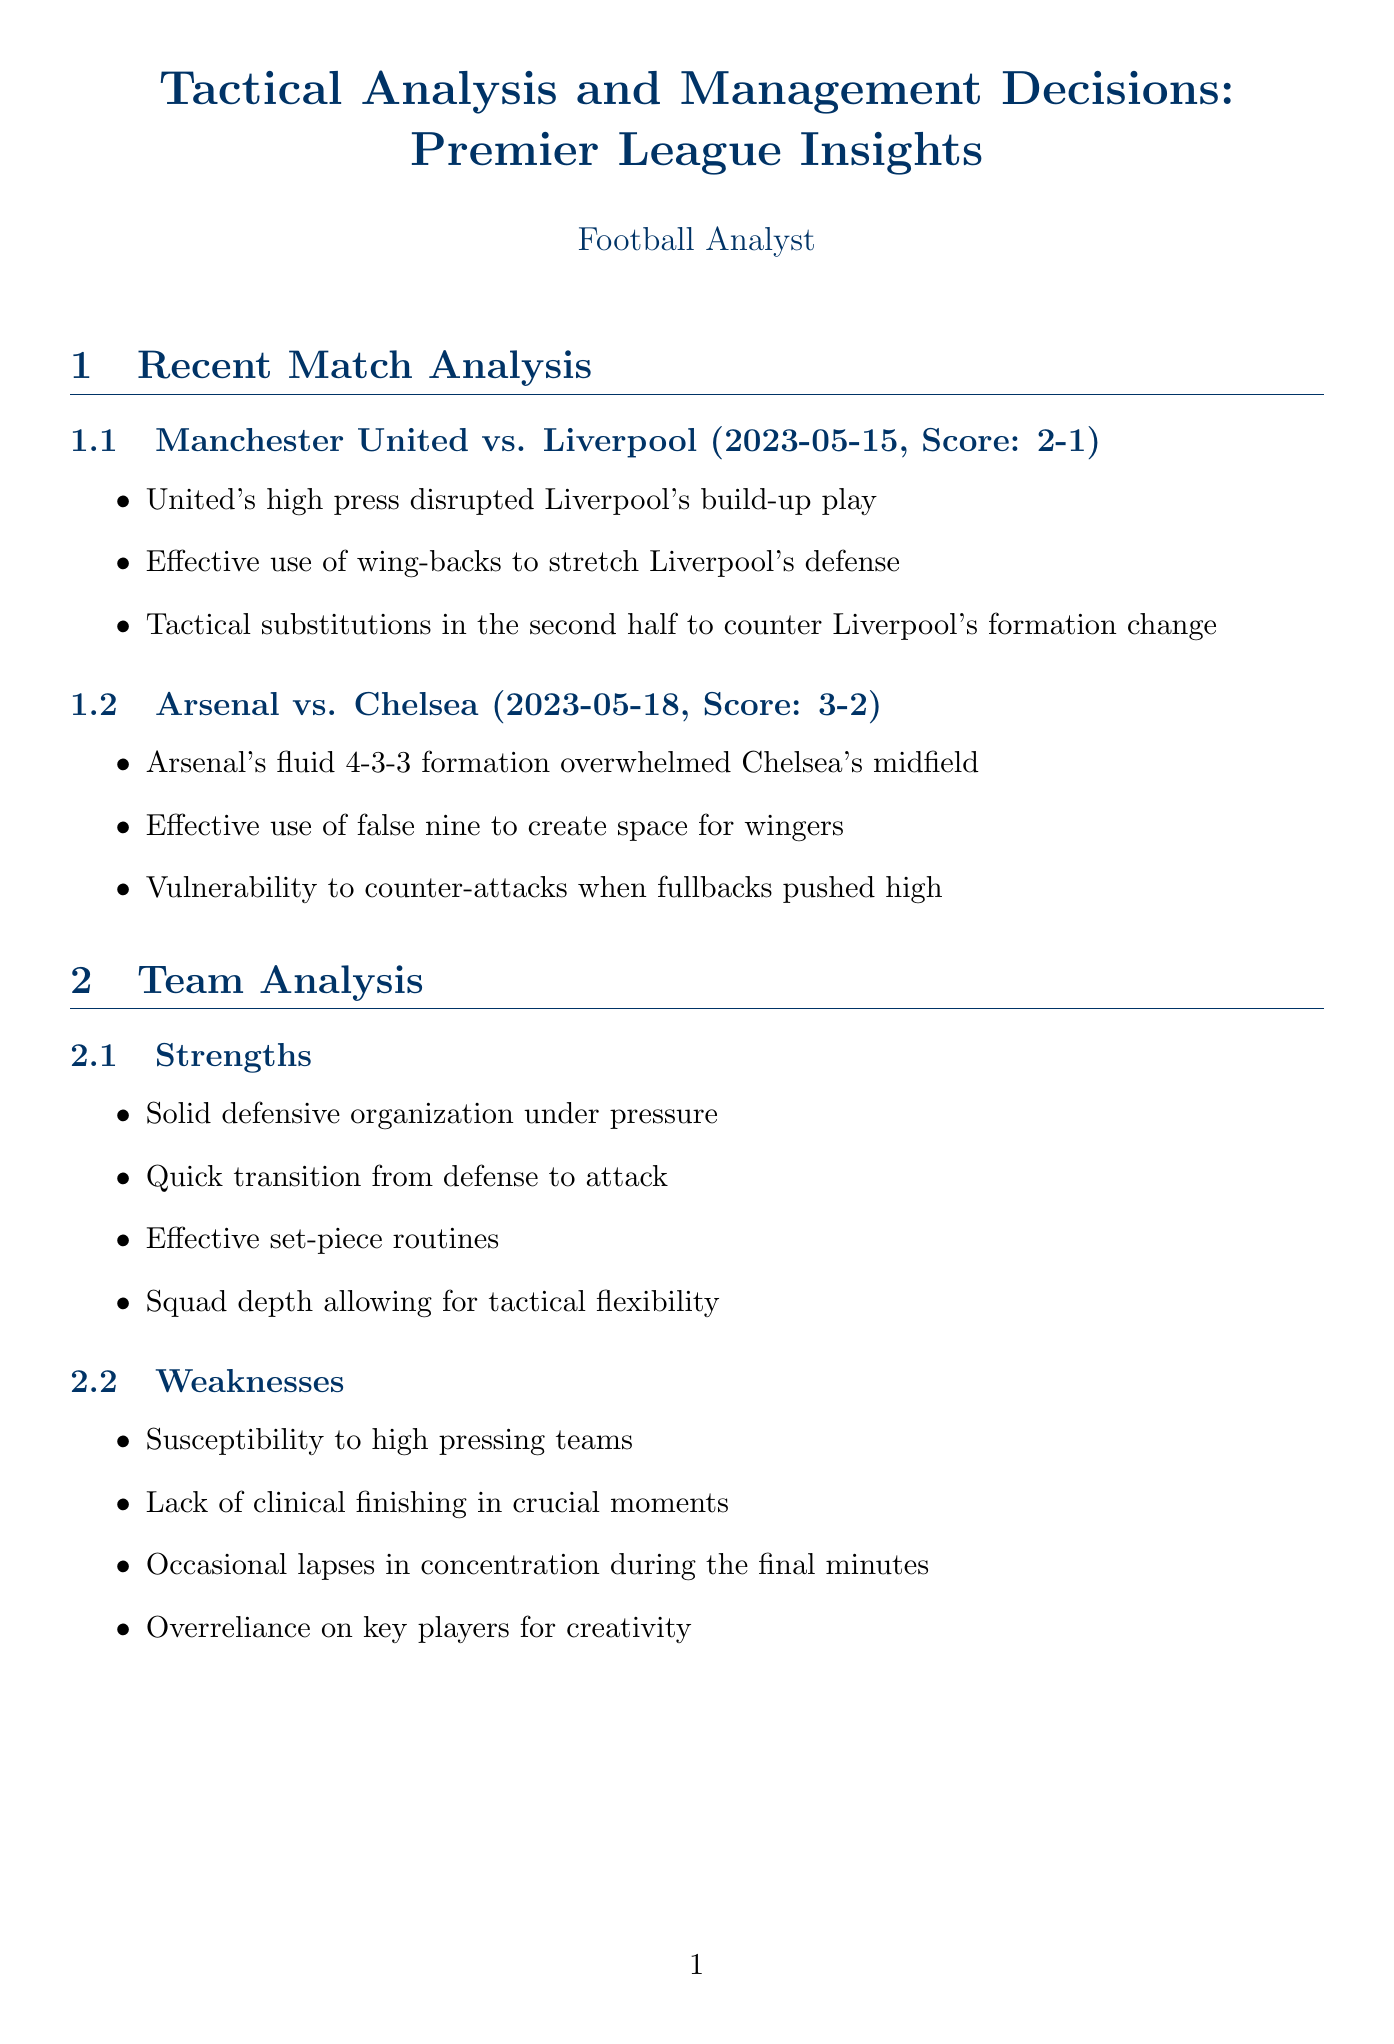what was the date of the Manchester United vs. Liverpool match? The date of the match is specified in the document as May 15, 2023.
Answer: 2023-05-15 what was the score of the Arsenal vs. Chelsea match? The score of the match is mentioned in the document as 3-2.
Answer: 3-2 who was the new manager for Tottenham Hotspur? The document names Ange Postecoglou as the new manager.
Answer: Ange Postecoglou what is a key strength of the 4-3-3 formation? The document lists providing width in attack as a strength of the 4-3-3 formation.
Answer: Provides width in attack how much did Barcelona pay for Raphinha? The document specifies the transfer fee for Raphinha as £55 million.
Answer: £55 million what is one of Arsenal's weaknesses mentioned in the document? The document states that vulnerability to counter-attacks is one of Arsenal's weaknesses.
Answer: Vulnerability to counter-attacks which player is highlighted for having creative passing? Bruno Fernandes is identified in the document for having creative passing as a strength.
Answer: Bruno Fernandes what tactical trend is mentioned in the league context? The document mentions the rise of inverted full-backs as a tactical trend.
Answer: Rise of inverted full-backs 